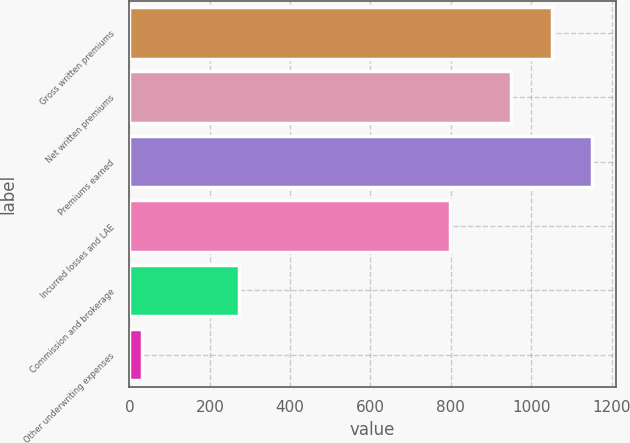Convert chart. <chart><loc_0><loc_0><loc_500><loc_500><bar_chart><fcel>Gross written premiums<fcel>Net written premiums<fcel>Premiums earned<fcel>Incurred losses and LAE<fcel>Commission and brokerage<fcel>Other underwriting expenses<nl><fcel>1050.61<fcel>948.8<fcel>1152.42<fcel>798.2<fcel>273.3<fcel>32.2<nl></chart> 